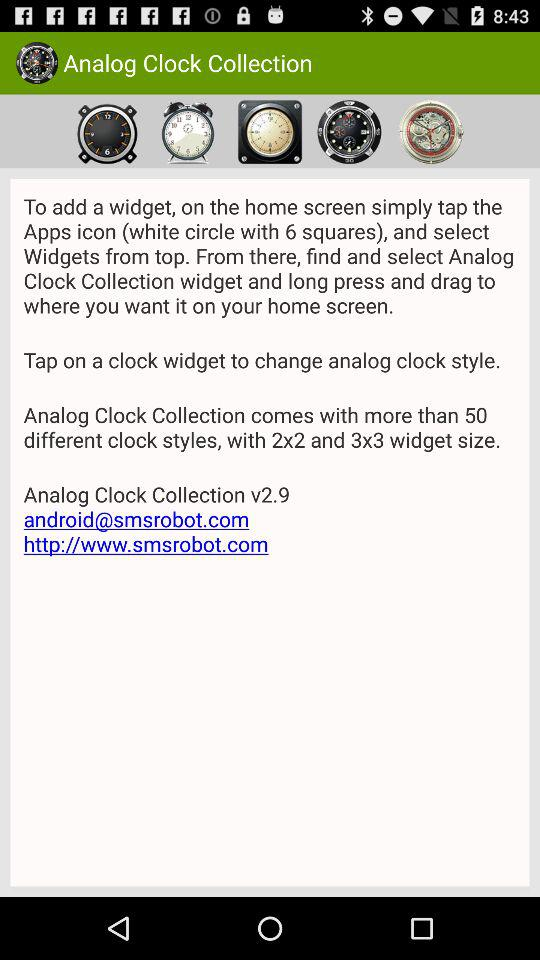What is the version of "Analog Clock Collection"? The version of "Analog Clock Collection" is v2.9. 